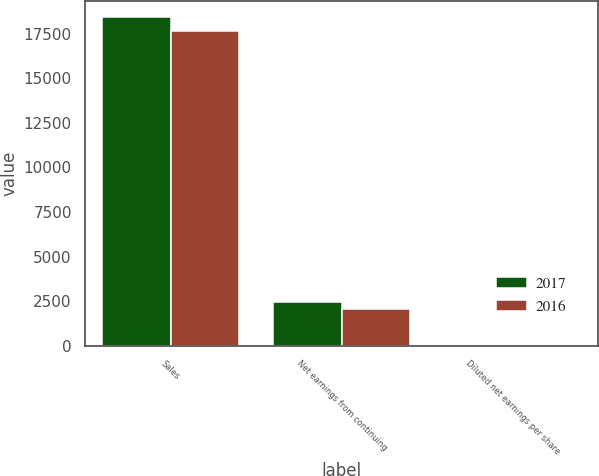<chart> <loc_0><loc_0><loc_500><loc_500><stacked_bar_chart><ecel><fcel>Sales<fcel>Net earnings from continuing<fcel>Diluted net earnings per share<nl><fcel>2017<fcel>18433.8<fcel>2467.8<fcel>3.5<nl><fcel>2016<fcel>17660.4<fcel>2072.7<fcel>2.96<nl></chart> 